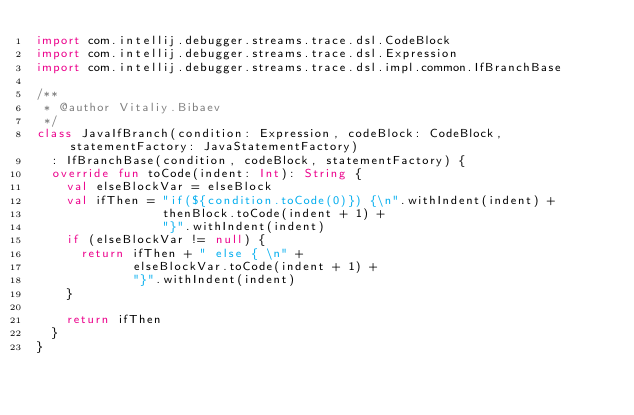<code> <loc_0><loc_0><loc_500><loc_500><_Kotlin_>import com.intellij.debugger.streams.trace.dsl.CodeBlock
import com.intellij.debugger.streams.trace.dsl.Expression
import com.intellij.debugger.streams.trace.dsl.impl.common.IfBranchBase

/**
 * @author Vitaliy.Bibaev
 */
class JavaIfBranch(condition: Expression, codeBlock: CodeBlock, statementFactory: JavaStatementFactory)
  : IfBranchBase(condition, codeBlock, statementFactory) {
  override fun toCode(indent: Int): String {
    val elseBlockVar = elseBlock
    val ifThen = "if(${condition.toCode(0)}) {\n".withIndent(indent) +
                 thenBlock.toCode(indent + 1) +
                 "}".withIndent(indent)
    if (elseBlockVar != null) {
      return ifThen + " else { \n" +
             elseBlockVar.toCode(indent + 1) +
             "}".withIndent(indent)
    }

    return ifThen
  }
}</code> 